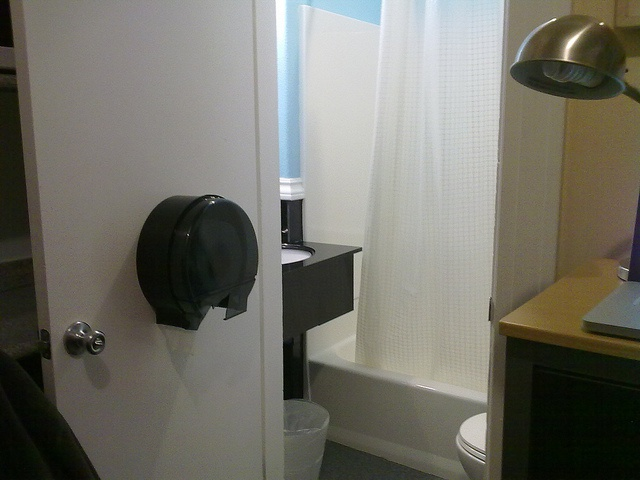Describe the objects in this image and their specific colors. I can see toilet in black, lightgray, gray, and darkgray tones and sink in black, gray, lightgray, and darkgray tones in this image. 